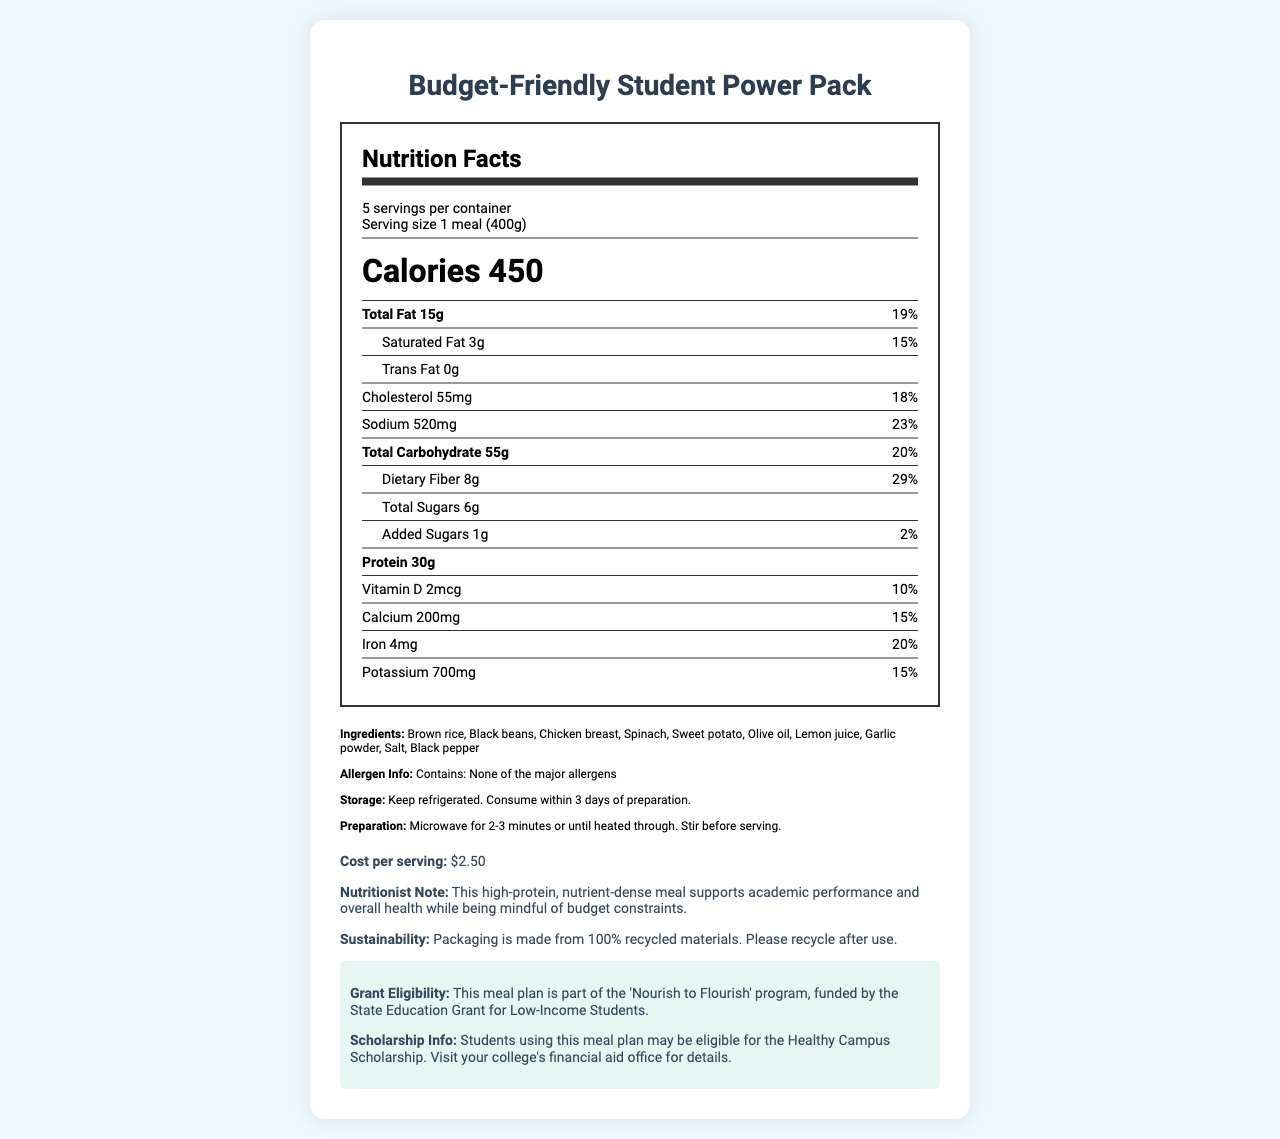what is the total fat content per serving? The document lists the total fat content as "Total Fat 15g" under the nutrient section.
Answer: 15g how many servings are there in one container? The serving information states "5 servings per container."
Answer: 5 what is the sodium daily value percentage in one serving? The document lists the daily value percentage of sodium as "Sodium 520mg 23%."
Answer: 23% how much protein is in one serving? In the nutrient section, it mentions "Protein 30g" as the amount per serving.
Answer: 30g what is the cost per serving? The additional info section states "Cost per serving: $2.50."
Answer: $2.50 what are the main ingredients in the meal? The document lists the ingredients in the ingredient section.
Answer: Brown rice, Black beans, Chicken breast, Spinach, Sweet potato, Olive oil, Lemon juice, Garlic powder, Salt, Black pepper is this meal allergen-free? The allergen information in the ingredients section states "Contains: None of the major allergens."
Answer: Yes what is the recommended storage condition for the meal? A. Freeze B. Keep at room temperature C. Keep refrigerated D. Store in a cool, dry place The storage instructions mention "Keep refrigerated."
Answer: C. Keep refrigerated what percentage of the daily value for fiber does a serving provide? A. 15% B. 29% C. 20% The nutrient section lists "Dietary Fiber 8g 29%" as the daily value percentage for fiber.
Answer: B. 29% which vitamin D value is correct? A. 5mcg B. 2mcg C. 8mcg D. 10mcg The nutrient section shows "Vitamin D 2mcg."
Answer: B. 2mcg is the packaging for the meal environmentally friendly? The sustainability info states that the packaging is made from 100% recycled materials.
Answer: Yes can this meal be part of a grant-funded program? The document specifies "This meal plan is part of the 'Nourish to Flourish' program, funded by the State Education Grant for Low-Income Students."
Answer: Yes how should one prepare this meal before consuming it? The preparation instructions in the ingredients section provide this information.
Answer: Microwave for 2-3 minutes or until heated through. Stir before serving. does the meal contain enough information to determine its effect on a student's cognitive performance? The document provides nutritional information and a nutritionist's note, but it does not offer scientific data on cognitive performance.
Answer: Not enough information summarize the main idea of the document. The document aims to highlight that the meal is nutritious, budget-friendly, allergen-free, and environmentally sustainable, while also being eligible for specific grants and scholarships.
Answer: The document provides detailed nutritional information, ingredients, preparation, storage instructions, and additional benefits of the Budget-Friendly Student Power Pack, a high-protein meal designed for low-income college students. 